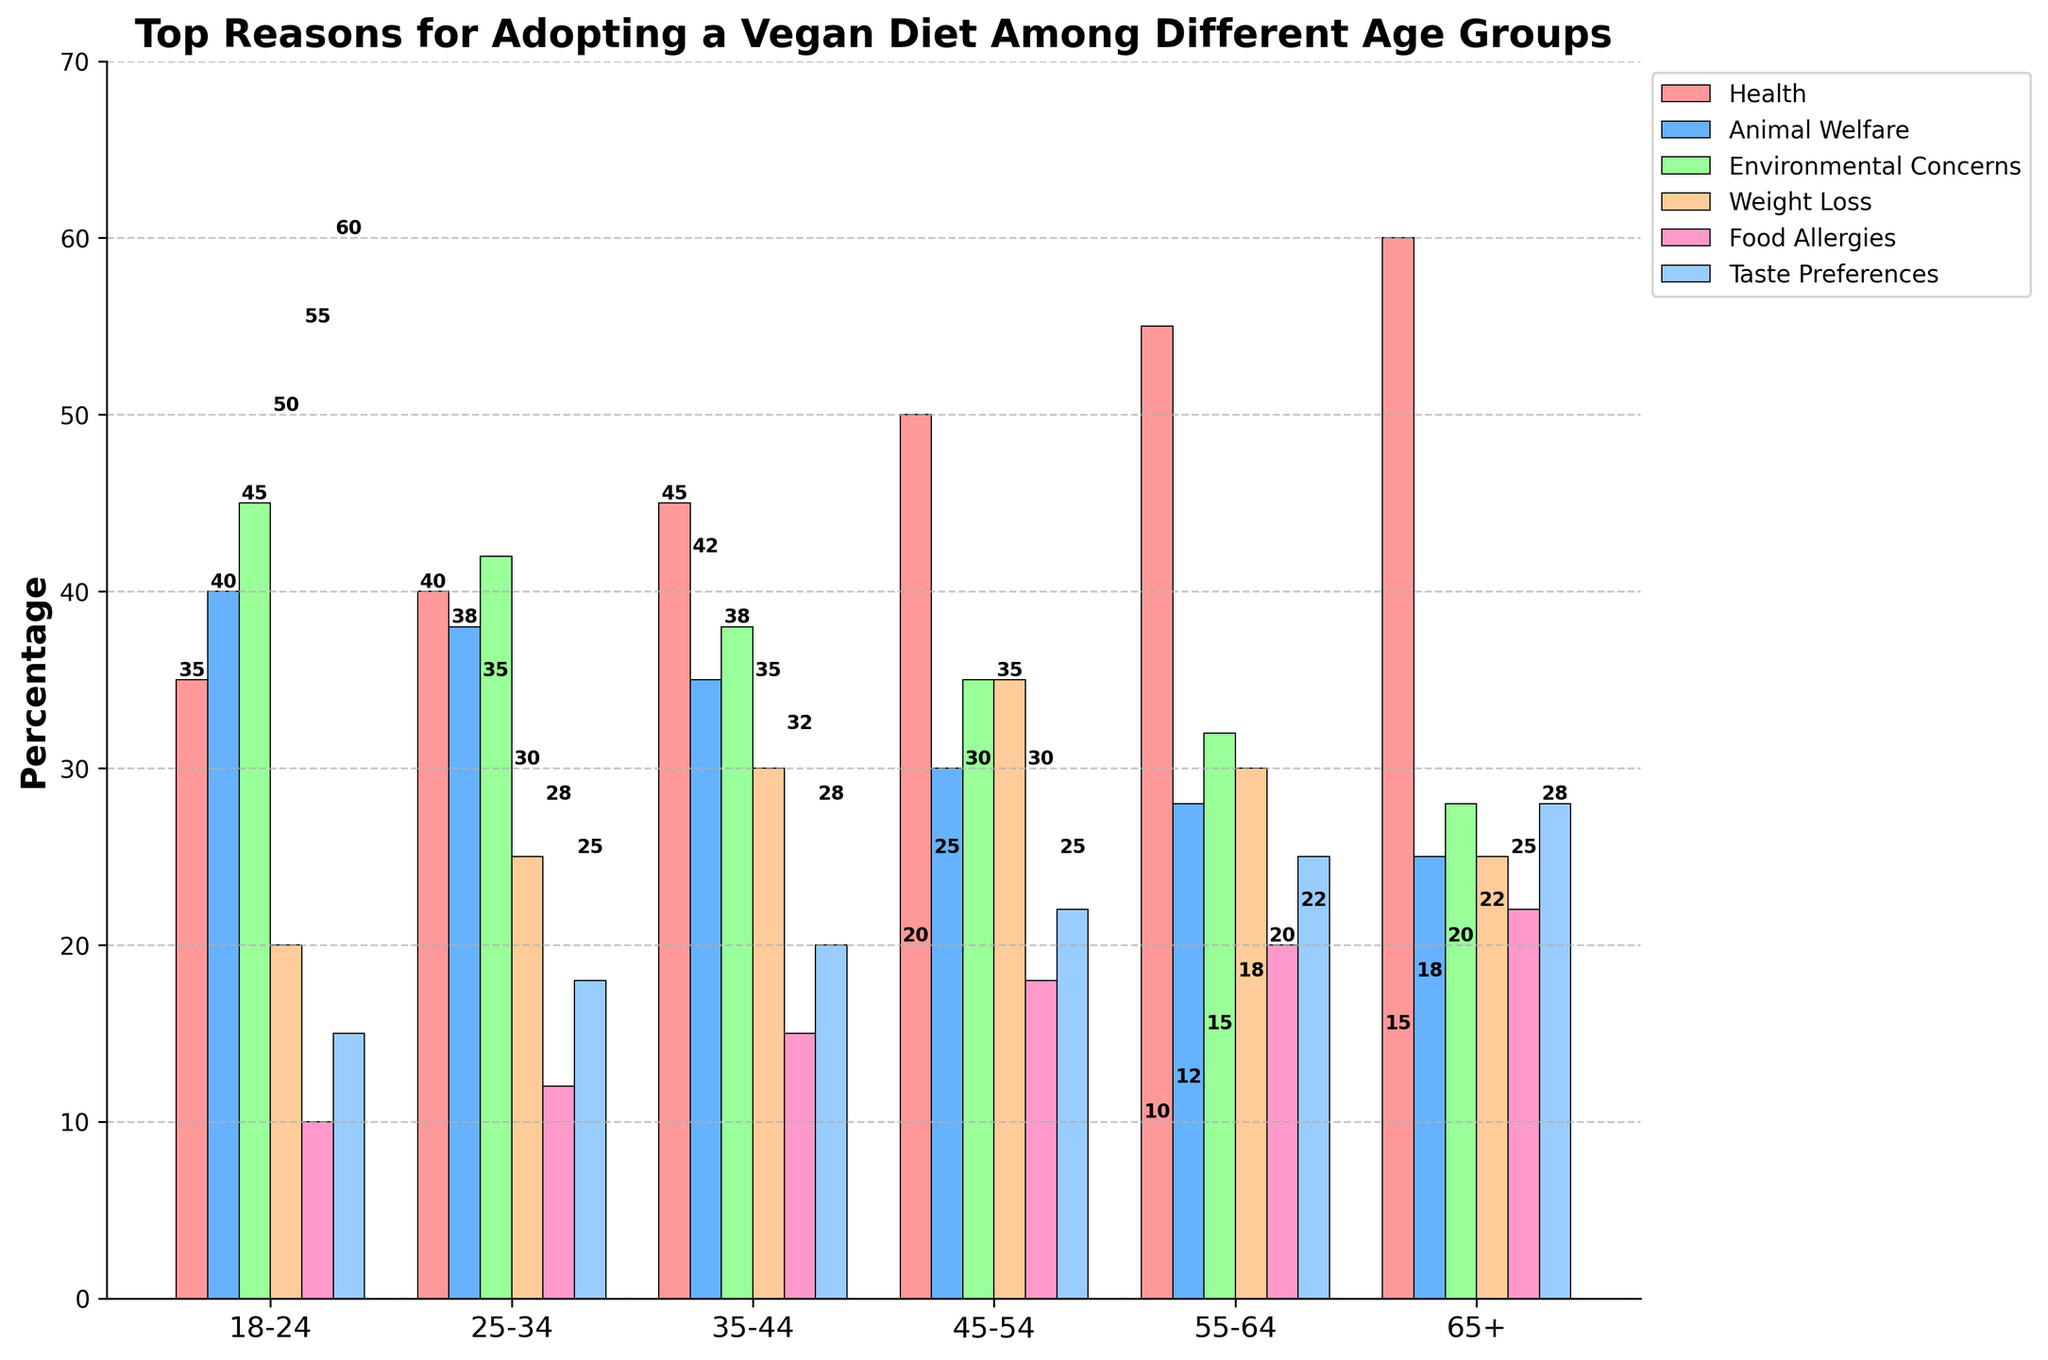What is the most common reason for adopting a vegan diet among the 18-24 age group? Look at the bars for the 18-24 age group and identify the highest bar. The "Environmental Concerns" bar is the tallest.
Answer: Environmental Concerns Which age group has the highest percentage attributed to health as a reason? Compare the heights of the "Health" bars across all age groups. The tallest bar is in the 65+ age group.
Answer: 65+ How much greater is the percentage for taste preferences in the 65+ age group compared to the 18-24 age group? Look at the "Taste Preferences" bars for both age groups. 65+ is 28%, and 18-24 is 15%. Subtract 15 from 28.
Answer: 13% What is the average percentage of environmental concerns across all age groups? Sum the "Environmental Concerns" values (45 + 42 + 38 + 35 + 32 + 28) = 220. Divide by the number of age groups, which is 6. 220 / 6 = 36.67
Answer: 36.67% What visual trend can be observed for the health reason across increasing age groups? Examine the heights of the "Health" bars from left to right. The bars become progressively taller as age increases.
Answer: Increasing trend Which age group shows a higher concern for food allergies compared to weight loss? Compare the "Food Allergies" and "Weight Loss" bars within each age group. The 65+ age group has a higher "Food Allergies" bar (22%) compared to "Weight Loss" (25%).
Answer: 65+ What is the sum of percentages for animal welfare and environmental concerns in the 45-54 age group? Add the "Animal Welfare" (30%) and "Environmental Concerns" (35%) values. 30 + 35 = 65
Answer: 65% Which two age groups have equal percentages for animal welfare? Compare bars for "Animal Welfare". 18-24 shows 40% and so does 25-34.
Answer: 18-24 and 25-34 For the 55-64 age group, what is the total percentage for health, weight loss, and taste preferences combined? Add the values for "Health" (55%), "Weight Loss" (30%), and "Taste Preferences" (25%). 55 + 30 + 25 = 110.
Answer: 110% 